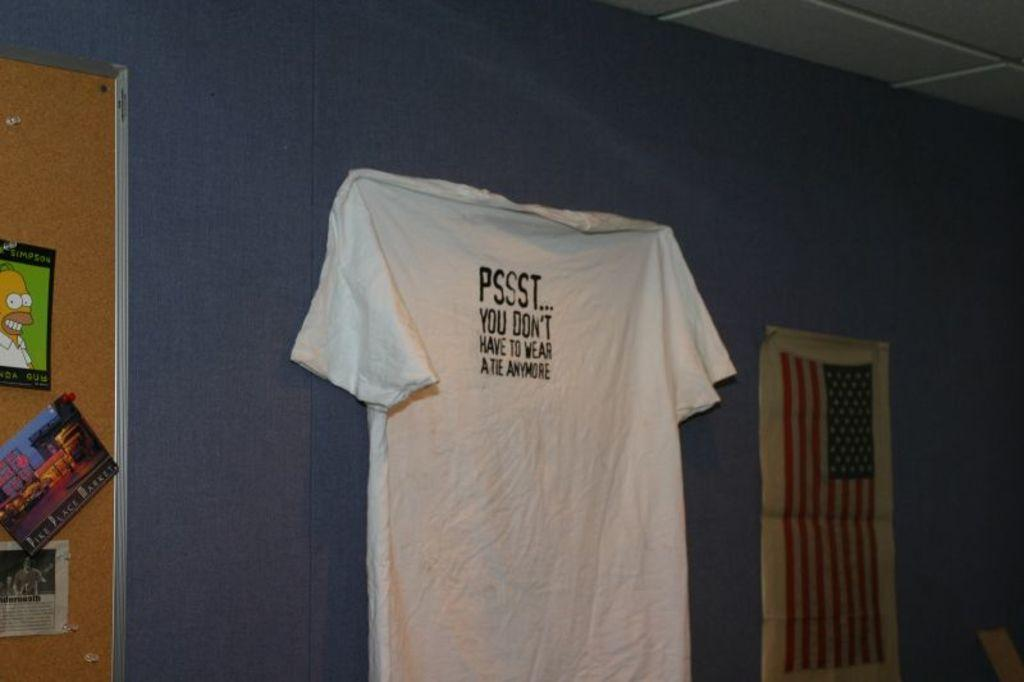<image>
Present a compact description of the photo's key features. a psssst t shirt that is on the wall 